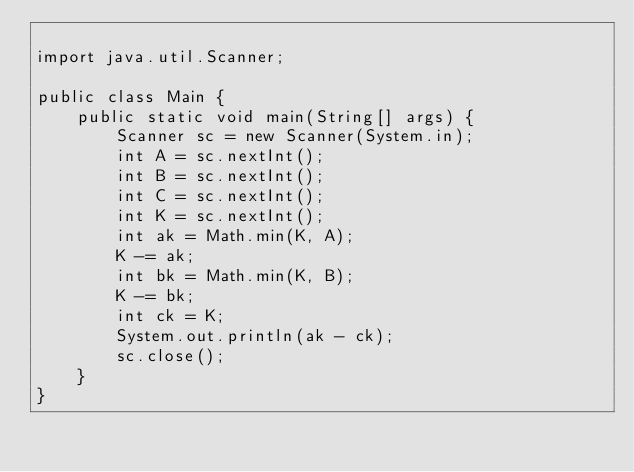<code> <loc_0><loc_0><loc_500><loc_500><_Java_>
import java.util.Scanner;

public class Main {
	public static void main(String[] args) {
		Scanner sc = new Scanner(System.in);
		int A = sc.nextInt();
		int B = sc.nextInt();
		int C = sc.nextInt();
		int K = sc.nextInt();
		int ak = Math.min(K, A);
		K -= ak;
		int bk = Math.min(K, B);
		K -= bk;
		int ck = K;
		System.out.println(ak - ck);
		sc.close();
	}
}
</code> 